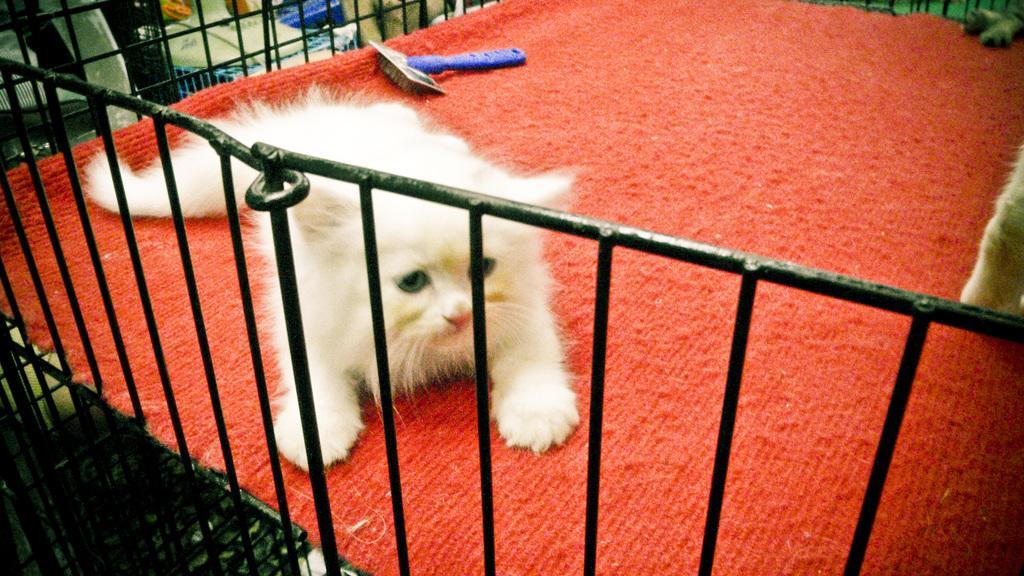Please provide a concise description of this image. In this picture we can observe a white color cat on the red color carpet. There is a railing which is in black color. 